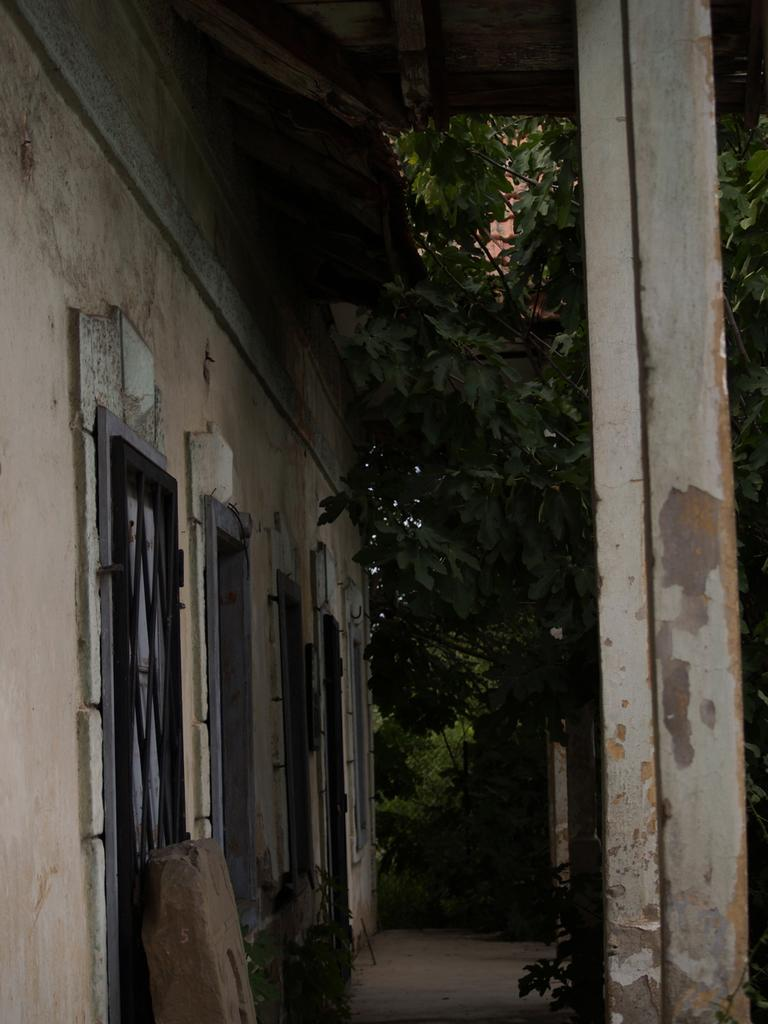What type of structure is visible in the image? There is a house in the image. What is the main architectural feature in the image? There is a wall in the image. What type of barrier can be seen in the image? There is a grille in the image. What vertical structure is present in the image? There is a pole in the image. What type of vegetation is present in the image? There are plants in the image. What type of pathway is visible in the image? There is a walkway in the image. How many objects can be seen in the image? There are a few objects in the image. What is visible at the top of the image? The ceiling is visible at the top of the image. How many apples are hanging from the pole in the image? There are no apples present in the image. What type of harmony is being played in the background of the image? There is no music or harmony present in the image. 